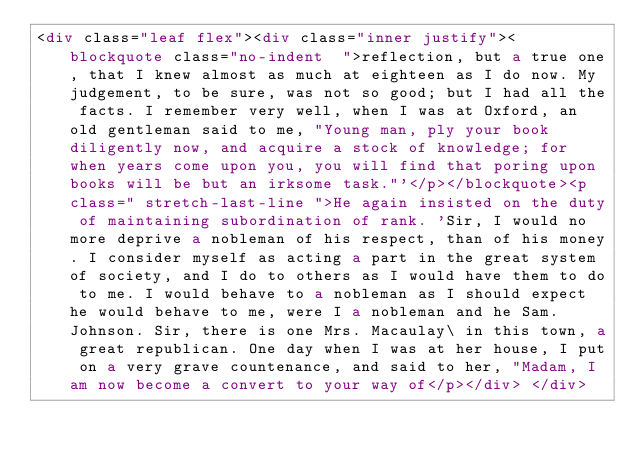Convert code to text. <code><loc_0><loc_0><loc_500><loc_500><_HTML_><div class="leaf flex"><div class="inner justify"><blockquote class="no-indent  ">reflection, but a true one, that I knew almost as much at eighteen as I do now. My judgement, to be sure, was not so good; but I had all the facts. I remember very well, when I was at Oxford, an old gentleman said to me, "Young man, ply your book diligently now, and acquire a stock of knowledge; for when years come upon you, you will find that poring upon books will be but an irksome task."'</p></blockquote><p class=" stretch-last-line ">He again insisted on the duty of maintaining subordination of rank. 'Sir, I would no more deprive a nobleman of his respect, than of his money. I consider myself as acting a part in the great system of society, and I do to others as I would have them to do to me. I would behave to a nobleman as I should expect he would behave to me, were I a nobleman and he Sam. Johnson. Sir, there is one Mrs. Macaulay\ in this town, a great republican. One day when I was at her house, I put on a very grave countenance, and said to her, "Madam, I am now become a convert to your way of</p></div> </div></code> 